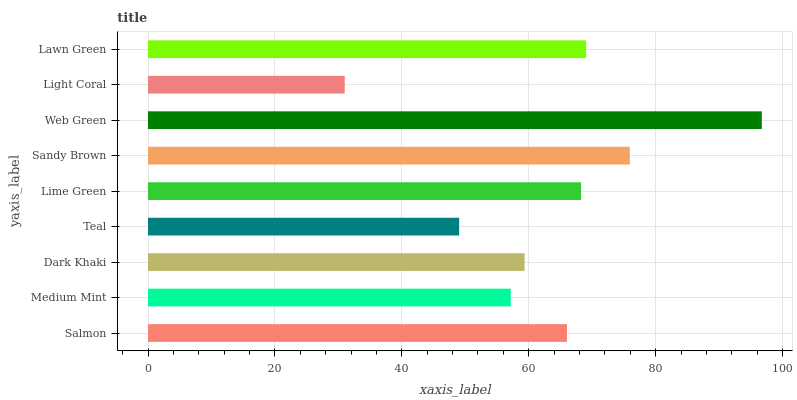Is Light Coral the minimum?
Answer yes or no. Yes. Is Web Green the maximum?
Answer yes or no. Yes. Is Medium Mint the minimum?
Answer yes or no. No. Is Medium Mint the maximum?
Answer yes or no. No. Is Salmon greater than Medium Mint?
Answer yes or no. Yes. Is Medium Mint less than Salmon?
Answer yes or no. Yes. Is Medium Mint greater than Salmon?
Answer yes or no. No. Is Salmon less than Medium Mint?
Answer yes or no. No. Is Salmon the high median?
Answer yes or no. Yes. Is Salmon the low median?
Answer yes or no. Yes. Is Medium Mint the high median?
Answer yes or no. No. Is Web Green the low median?
Answer yes or no. No. 